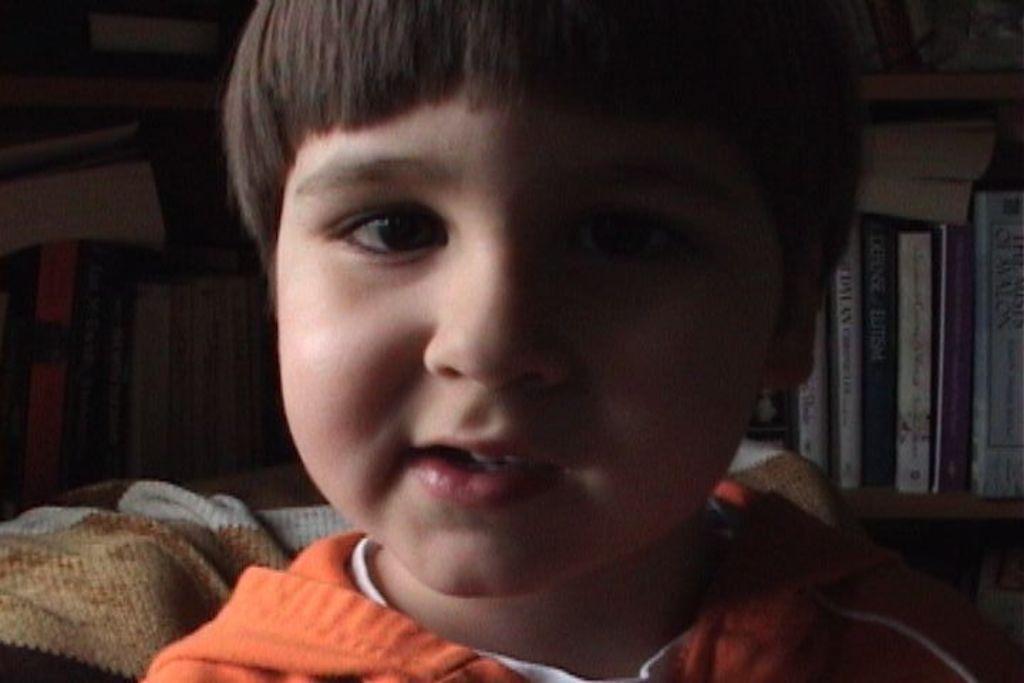Could you give a brief overview of what you see in this image? In this image I can see a kid. In the background, I can see the books. 